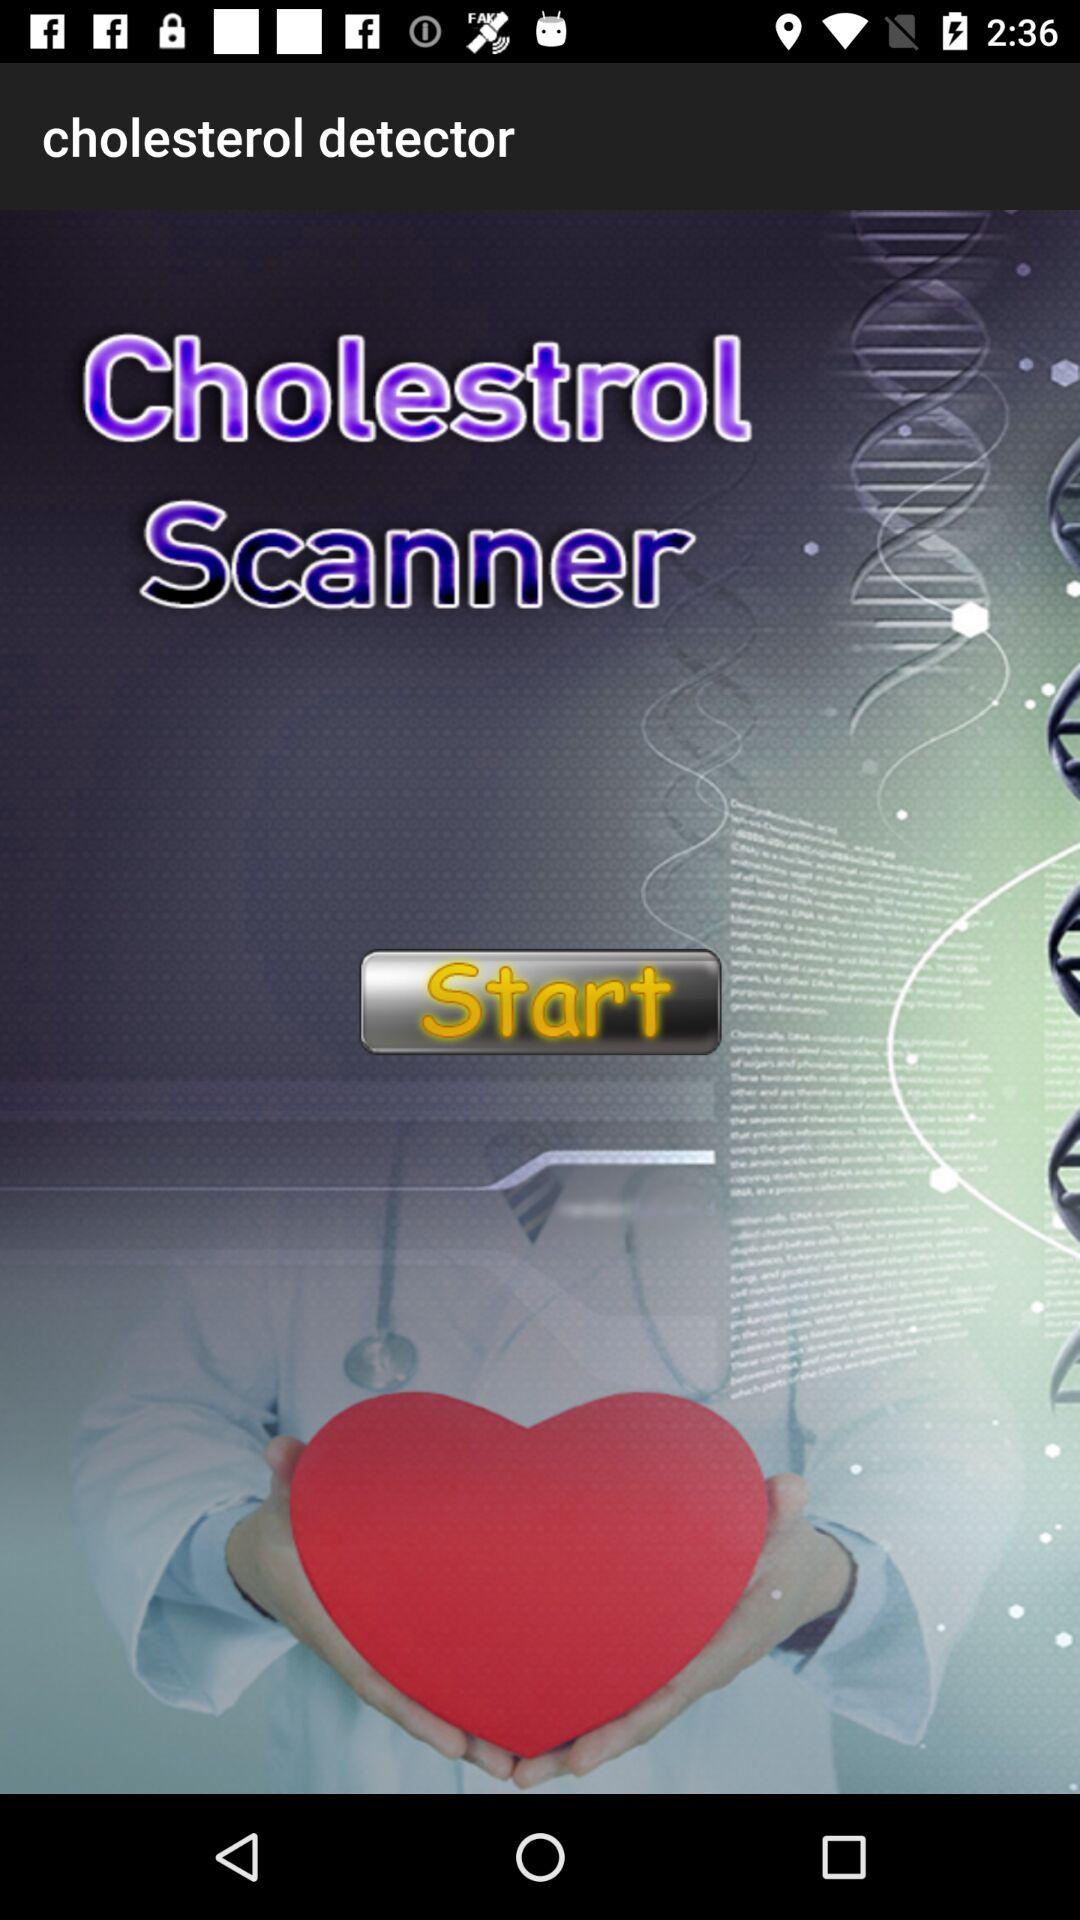When was the last cholesterol scan?
When the provided information is insufficient, respond with <no answer>. <no answer> 